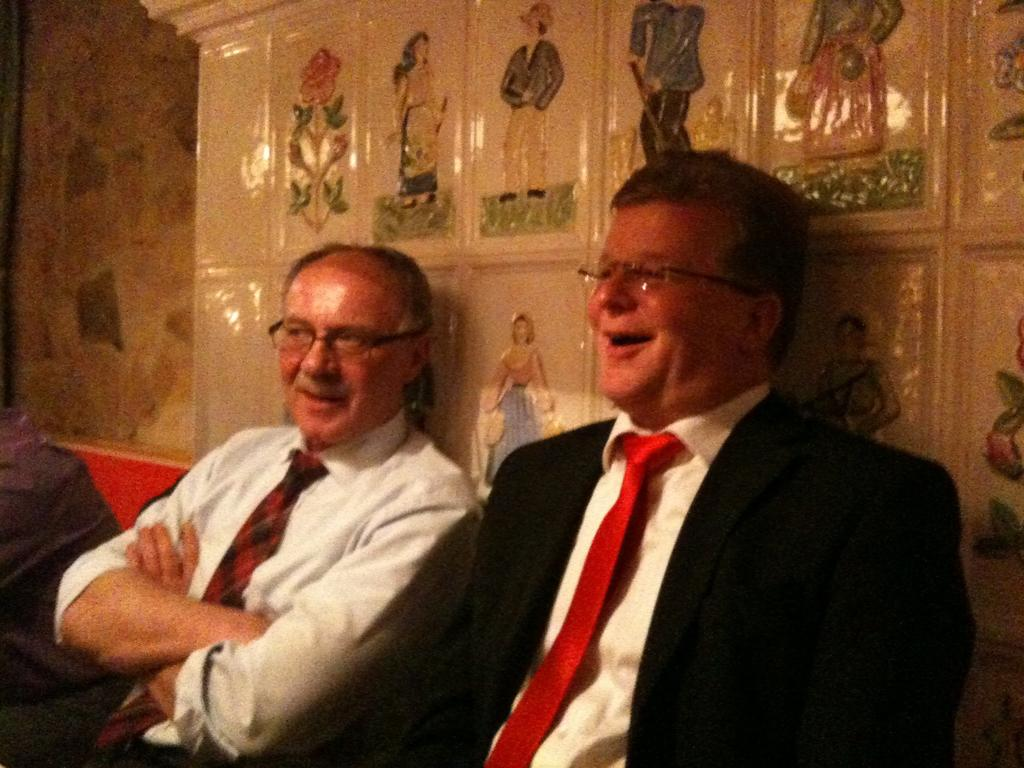How many people are in the image? There are two persons in the image. What can be seen in the background of the image? There is a wall visible in the background of the image. What is on the wall in the image? There are pictures on the wall. What type of grain can be seen falling from the sky in the image? There is no grain falling from the sky in the image; it only features two persons and a wall with pictures. 